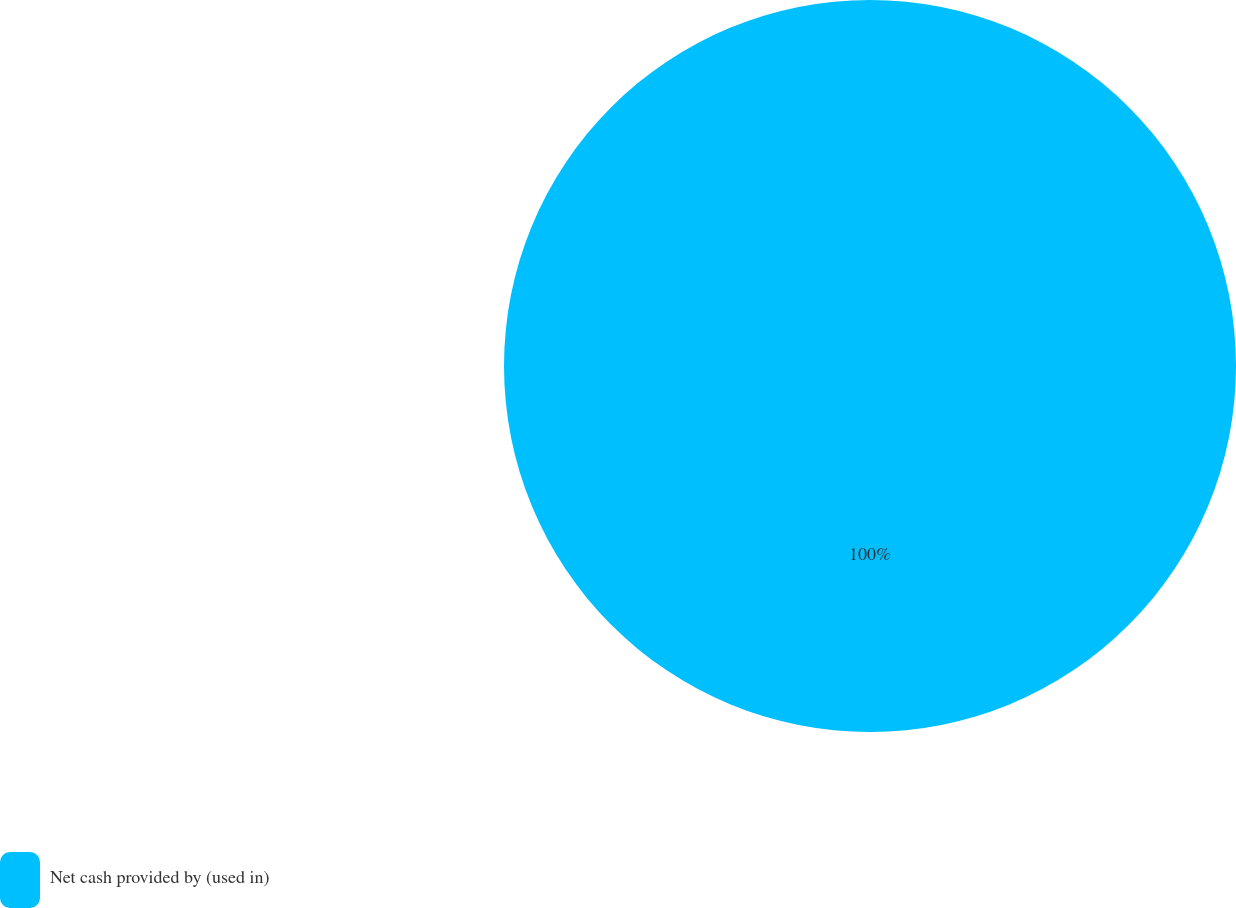Convert chart to OTSL. <chart><loc_0><loc_0><loc_500><loc_500><pie_chart><fcel>Net cash provided by (used in)<nl><fcel>100.0%<nl></chart> 